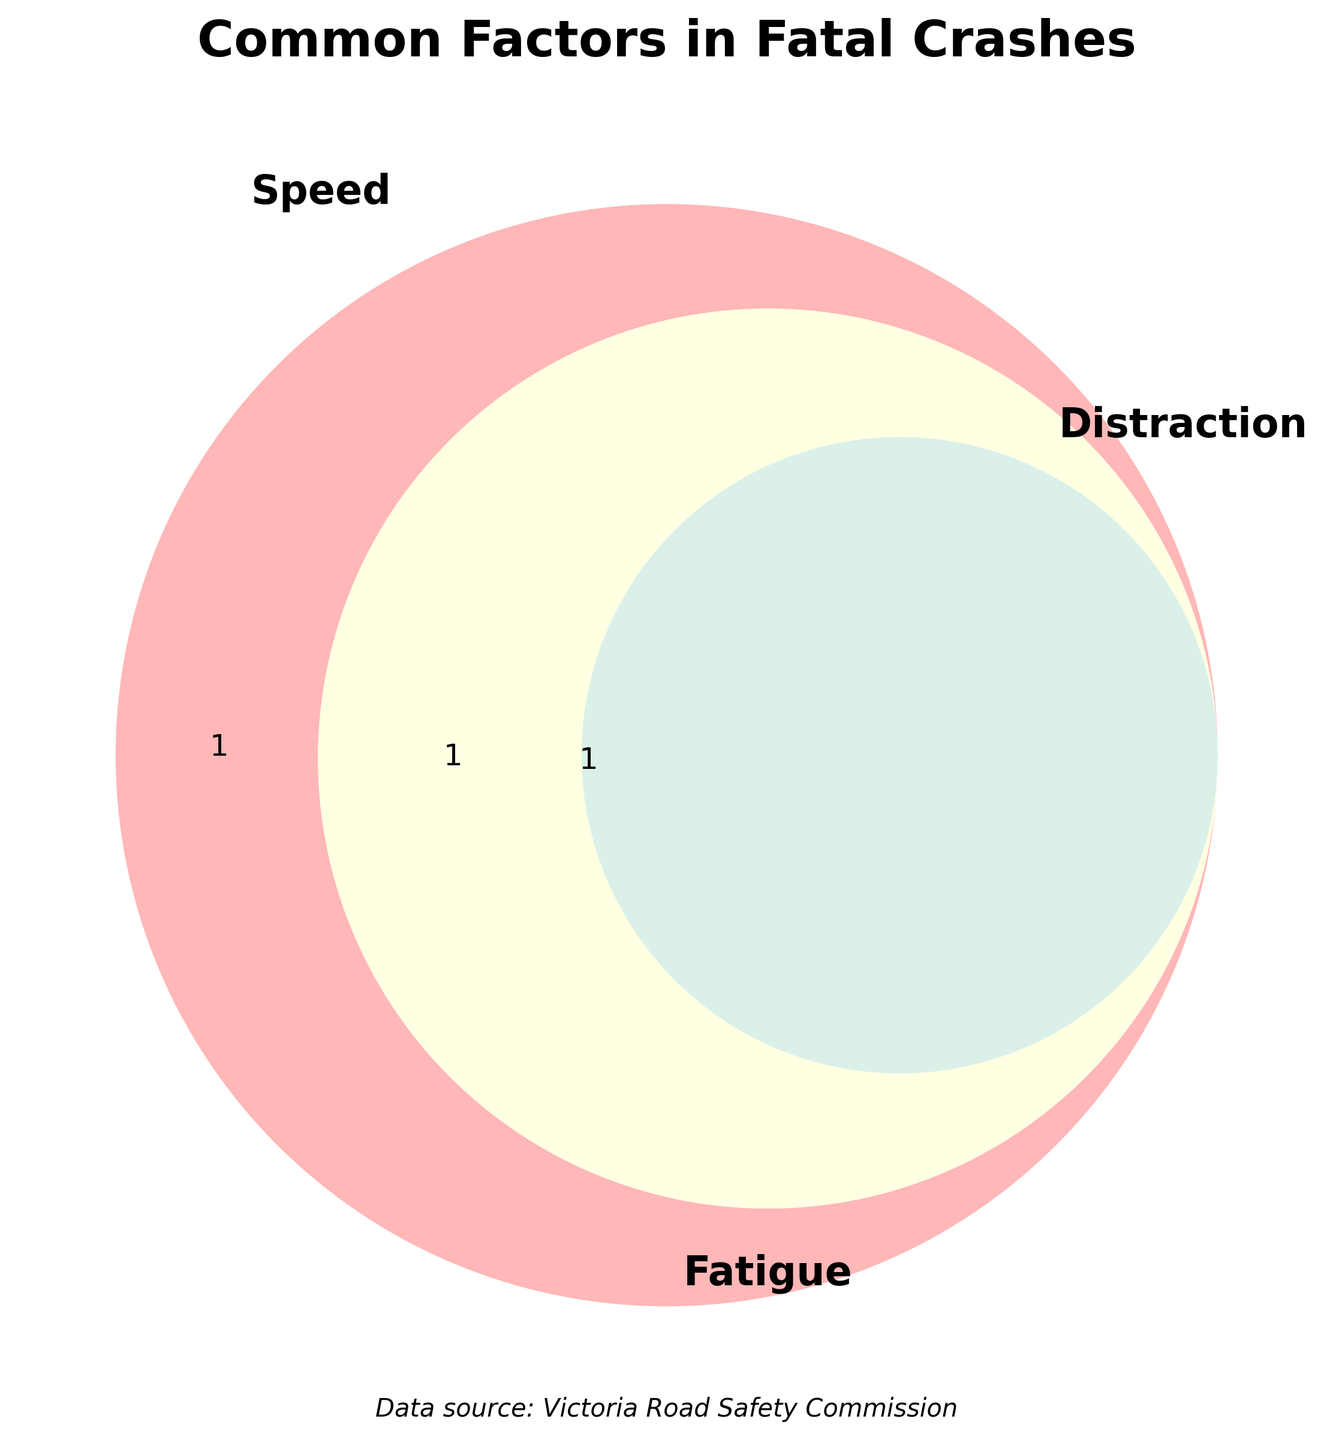What's the title of the figure? The title is usually located at the top of the diagram. It helps viewers understand the purpose of the figure.
Answer: Common Factors in Fatal Crashes Which three factors are being compared in the Venn diagram? The three overlapping circles in the Venn diagram each represent one of the factors being compared.
Answer: Speed, Distraction, Fatigue How many common factors are shared between all three categories: speed, distraction, and fatigue? This can be determined by looking at the intersection of all three circles.
Answer: 3 Do "Wet road conditions" factor in any other category besides speed? To check this, we look at the part of the Speed circle that doesn't overlap with the other two circles.
Answer: No Which is the only category that includes "Eating while driving"? This involves finding the specific segment of the Venn diagram that represents only one category containing "Eating while driving".
Answer: Distraction Name one common factor that is shared between speed and fatigue but not distraction. This involves checking the specific overlapping area between Speed and Fatigue which doesn't include Distraction.
Answer: None Are there more common factors related to just one category or to multiple categories? We need to count the factors in each segment of the Venn diagram.
Answer: Multiple categories Which common factor is shared between speed and distraction but not fatigue? Examine the diagram segment where Speed and Distraction overlap without including Fatigue.
Answer: None 